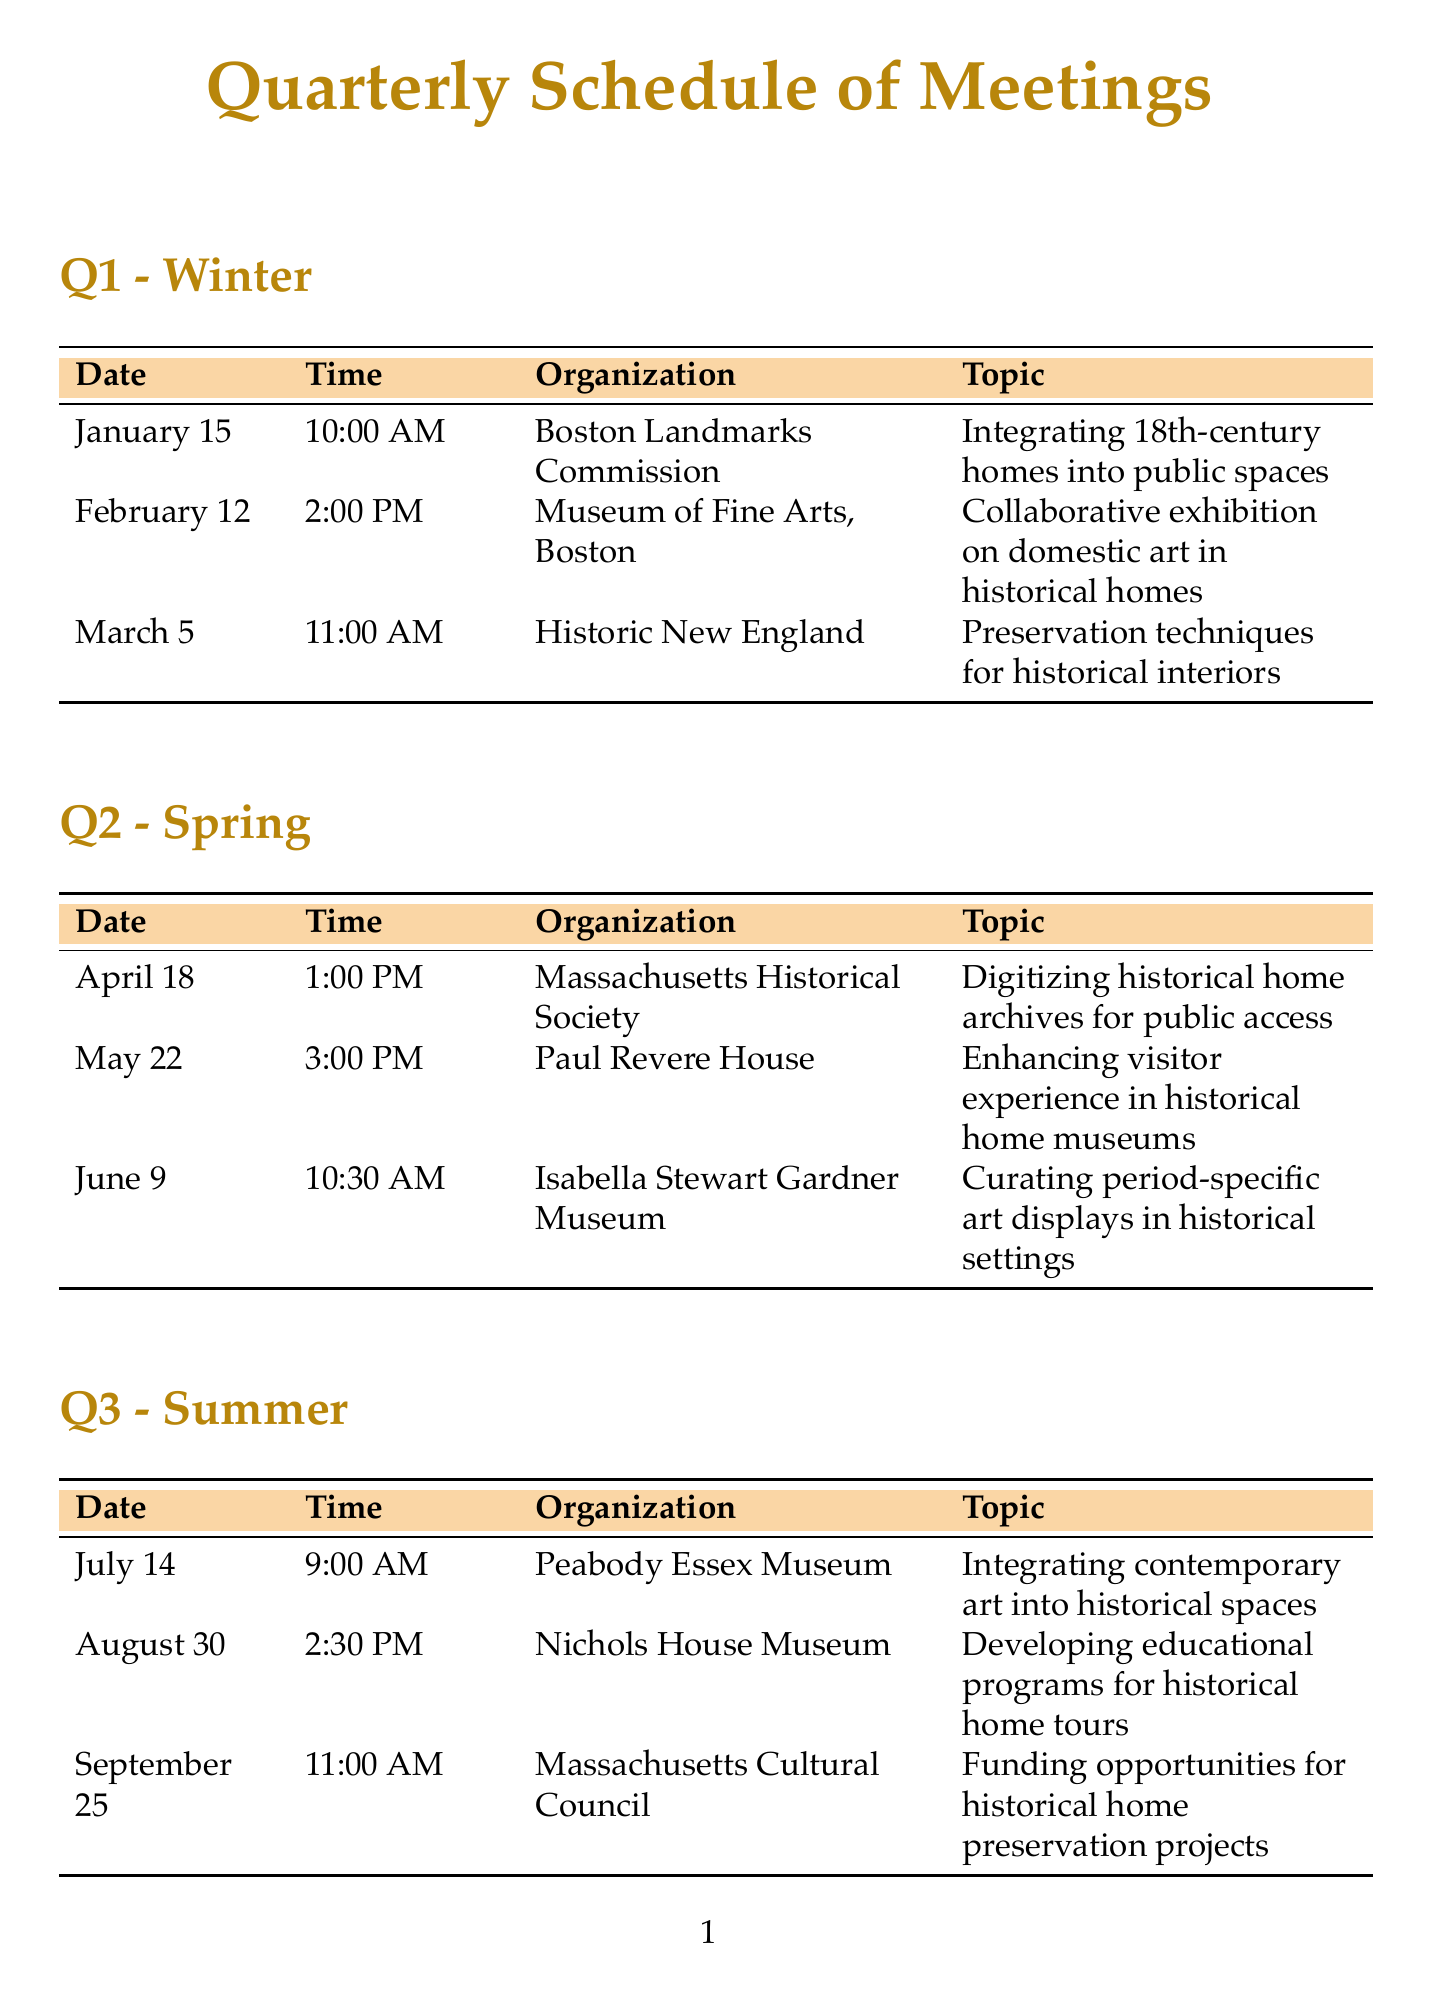What is the date of the meeting with the Boston Landmarks Commission? The date for the meeting is found in the schedule under Q1, and it shows "January 15".
Answer: January 15 What time is the meeting on March 5? The time is stated next to the date of the meeting in the Q1 section, indicating "11:00 AM".
Answer: 11:00 AM Which organization is hosting the meeting about digitizing historical home archives? The organization is listed for the Q2 meeting in April, which identifies the "Massachusetts Historical Society".
Answer: Massachusetts Historical Society How many meetings are scheduled in Q3? By counting the entries in the Q3 section, I can see there are "3" meetings listed.
Answer: 3 What topic will the Harvard Art Museums discuss? The topic is detailed in the Q4 section for the November meeting, stating "Collaborative research on New England furniture in historical homes".
Answer: Collaborative research on New England furniture in historical homes Which month has a meeting focused on enhancing visitor experience? The meeting is mentioned in the Q2 section for May, specifically addressing visitor experience at the Paul Revere House.
Answer: May What is the location for the October 7 meeting? The location is mentioned next to the meeting details in Q4, specifying "Lyman Estate, Waltham".
Answer: Lyman Estate, Waltham How often are these meetings held? The schedule indicates these meetings occur every quarter, hence they are held "quarterly".
Answer: quarterly What is the focus of the meeting in June? The meeting topic is listed under Q2 for June, mentioning "Curating period-specific art displays in historical settings".
Answer: Curating period-specific art displays in historical settings 